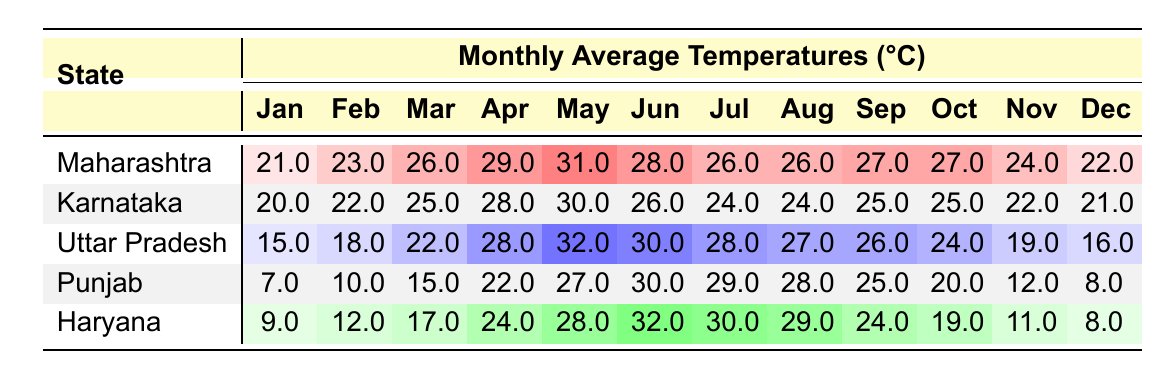What is the average temperature in Maharashtra during May? The table shows that the average temperature in Maharashtra during May is 31.0°C.
Answer: 31.0°C Which state has the highest average temperature in July? In the table, Haryana shows a temperature of 30.0°C in July, which is higher than the other states listed.
Answer: Haryana What is the average temperature in Uttar Pradesh from January to March? We calculate the average temperature by adding January (15.0°C), February (18.0°C), and March (22.0°C): (15.0 + 18.0 + 22.0) = 55.0°C. Divided by 3 gives an average temperature of 55.0 / 3 = 18.33°C.
Answer: 18.33°C Is the average temperature in Karnataka higher in June than in May? The table indicates that the average temperature for June in Karnataka is 26.0°C and for May it is 30.0°C, showing that June's temperature is lower than May's.
Answer: No What is the difference in average temperature between Punjab in January and Karnataka in January? Punjab has an average temperature of 7.0°C in January, while Karnataka has 20.0°C. The difference is calculated as 20.0 - 7.0 = 13.0°C.
Answer: 13.0°C Which state has the lowest average temperature for the month of February? Referring to the table, Punjab shows the lowest temperature of 10.0°C in February compared to the others.
Answer: Punjab What is the total average temperature for Haryana for the months of April to June? The average temperatures for April (24.0°C), May (28.0°C), and June (32.0°C) in Haryana add up to 24.0 + 28.0 + 32.0 = 84.0°C. Thus, the total is 84.0°C.
Answer: 84.0°C In which month does Uttar Pradesh experience the highest average temperature? Upon reviewing the data, May has the highest average temperature of 32.0°C in Uttar Pradesh.
Answer: May What is the average temperature for Maharashtra from October to December? The temperatures for Maharashtra in October (27.0°C), November (24.0°C), and December (22.0°C) sum to 27.0 + 24.0 + 22.0 = 73.0°C. The average is then calculated as 73.0 / 3 = 24.33°C.
Answer: 24.33°C 